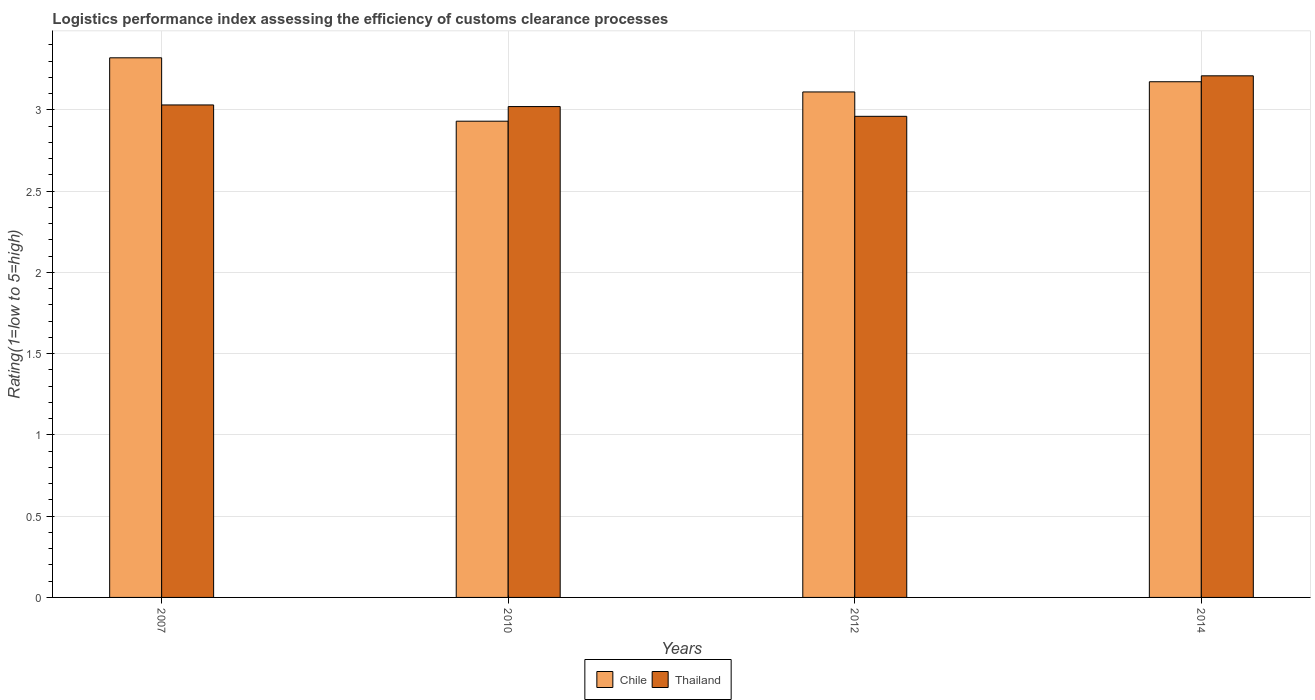How many groups of bars are there?
Offer a very short reply. 4. Are the number of bars per tick equal to the number of legend labels?
Your answer should be very brief. Yes. What is the Logistic performance index in Chile in 2007?
Provide a succinct answer. 3.32. Across all years, what is the maximum Logistic performance index in Thailand?
Offer a very short reply. 3.21. Across all years, what is the minimum Logistic performance index in Thailand?
Make the answer very short. 2.96. In which year was the Logistic performance index in Chile minimum?
Provide a succinct answer. 2010. What is the total Logistic performance index in Chile in the graph?
Make the answer very short. 12.53. What is the difference between the Logistic performance index in Thailand in 2007 and that in 2014?
Your answer should be compact. -0.18. What is the difference between the Logistic performance index in Chile in 2010 and the Logistic performance index in Thailand in 2012?
Keep it short and to the point. -0.03. What is the average Logistic performance index in Chile per year?
Provide a succinct answer. 3.13. In the year 2014, what is the difference between the Logistic performance index in Thailand and Logistic performance index in Chile?
Make the answer very short. 0.04. What is the ratio of the Logistic performance index in Thailand in 2007 to that in 2014?
Make the answer very short. 0.94. Is the Logistic performance index in Chile in 2007 less than that in 2014?
Offer a very short reply. No. Is the difference between the Logistic performance index in Thailand in 2007 and 2014 greater than the difference between the Logistic performance index in Chile in 2007 and 2014?
Ensure brevity in your answer.  No. What is the difference between the highest and the second highest Logistic performance index in Chile?
Offer a very short reply. 0.15. What is the difference between the highest and the lowest Logistic performance index in Chile?
Give a very brief answer. 0.39. Is the sum of the Logistic performance index in Chile in 2012 and 2014 greater than the maximum Logistic performance index in Thailand across all years?
Keep it short and to the point. Yes. What does the 1st bar from the left in 2007 represents?
Give a very brief answer. Chile. What does the 1st bar from the right in 2012 represents?
Your answer should be very brief. Thailand. How many years are there in the graph?
Provide a short and direct response. 4. What is the difference between two consecutive major ticks on the Y-axis?
Give a very brief answer. 0.5. Are the values on the major ticks of Y-axis written in scientific E-notation?
Give a very brief answer. No. Does the graph contain any zero values?
Offer a very short reply. No. Does the graph contain grids?
Provide a short and direct response. Yes. Where does the legend appear in the graph?
Offer a very short reply. Bottom center. What is the title of the graph?
Ensure brevity in your answer.  Logistics performance index assessing the efficiency of customs clearance processes. What is the label or title of the X-axis?
Provide a short and direct response. Years. What is the label or title of the Y-axis?
Make the answer very short. Rating(1=low to 5=high). What is the Rating(1=low to 5=high) of Chile in 2007?
Your answer should be compact. 3.32. What is the Rating(1=low to 5=high) in Thailand in 2007?
Provide a short and direct response. 3.03. What is the Rating(1=low to 5=high) of Chile in 2010?
Your answer should be very brief. 2.93. What is the Rating(1=low to 5=high) in Thailand in 2010?
Give a very brief answer. 3.02. What is the Rating(1=low to 5=high) of Chile in 2012?
Offer a very short reply. 3.11. What is the Rating(1=low to 5=high) in Thailand in 2012?
Keep it short and to the point. 2.96. What is the Rating(1=low to 5=high) of Chile in 2014?
Your answer should be compact. 3.17. What is the Rating(1=low to 5=high) of Thailand in 2014?
Your answer should be compact. 3.21. Across all years, what is the maximum Rating(1=low to 5=high) of Chile?
Offer a terse response. 3.32. Across all years, what is the maximum Rating(1=low to 5=high) of Thailand?
Provide a short and direct response. 3.21. Across all years, what is the minimum Rating(1=low to 5=high) in Chile?
Ensure brevity in your answer.  2.93. Across all years, what is the minimum Rating(1=low to 5=high) of Thailand?
Keep it short and to the point. 2.96. What is the total Rating(1=low to 5=high) in Chile in the graph?
Offer a very short reply. 12.53. What is the total Rating(1=low to 5=high) of Thailand in the graph?
Ensure brevity in your answer.  12.22. What is the difference between the Rating(1=low to 5=high) in Chile in 2007 and that in 2010?
Ensure brevity in your answer.  0.39. What is the difference between the Rating(1=low to 5=high) in Chile in 2007 and that in 2012?
Your answer should be compact. 0.21. What is the difference between the Rating(1=low to 5=high) of Thailand in 2007 and that in 2012?
Offer a very short reply. 0.07. What is the difference between the Rating(1=low to 5=high) in Chile in 2007 and that in 2014?
Keep it short and to the point. 0.15. What is the difference between the Rating(1=low to 5=high) of Thailand in 2007 and that in 2014?
Give a very brief answer. -0.18. What is the difference between the Rating(1=low to 5=high) in Chile in 2010 and that in 2012?
Your response must be concise. -0.18. What is the difference between the Rating(1=low to 5=high) of Thailand in 2010 and that in 2012?
Your response must be concise. 0.06. What is the difference between the Rating(1=low to 5=high) in Chile in 2010 and that in 2014?
Provide a succinct answer. -0.24. What is the difference between the Rating(1=low to 5=high) of Thailand in 2010 and that in 2014?
Your response must be concise. -0.19. What is the difference between the Rating(1=low to 5=high) in Chile in 2012 and that in 2014?
Give a very brief answer. -0.06. What is the difference between the Rating(1=low to 5=high) in Thailand in 2012 and that in 2014?
Offer a very short reply. -0.25. What is the difference between the Rating(1=low to 5=high) of Chile in 2007 and the Rating(1=low to 5=high) of Thailand in 2012?
Your answer should be compact. 0.36. What is the difference between the Rating(1=low to 5=high) in Chile in 2007 and the Rating(1=low to 5=high) in Thailand in 2014?
Make the answer very short. 0.11. What is the difference between the Rating(1=low to 5=high) in Chile in 2010 and the Rating(1=low to 5=high) in Thailand in 2012?
Offer a terse response. -0.03. What is the difference between the Rating(1=low to 5=high) in Chile in 2010 and the Rating(1=low to 5=high) in Thailand in 2014?
Provide a succinct answer. -0.28. What is the difference between the Rating(1=low to 5=high) in Chile in 2012 and the Rating(1=low to 5=high) in Thailand in 2014?
Your response must be concise. -0.1. What is the average Rating(1=low to 5=high) in Chile per year?
Your response must be concise. 3.13. What is the average Rating(1=low to 5=high) in Thailand per year?
Ensure brevity in your answer.  3.05. In the year 2007, what is the difference between the Rating(1=low to 5=high) of Chile and Rating(1=low to 5=high) of Thailand?
Your answer should be very brief. 0.29. In the year 2010, what is the difference between the Rating(1=low to 5=high) of Chile and Rating(1=low to 5=high) of Thailand?
Give a very brief answer. -0.09. In the year 2014, what is the difference between the Rating(1=low to 5=high) of Chile and Rating(1=low to 5=high) of Thailand?
Your answer should be compact. -0.04. What is the ratio of the Rating(1=low to 5=high) of Chile in 2007 to that in 2010?
Make the answer very short. 1.13. What is the ratio of the Rating(1=low to 5=high) in Thailand in 2007 to that in 2010?
Offer a very short reply. 1. What is the ratio of the Rating(1=low to 5=high) in Chile in 2007 to that in 2012?
Ensure brevity in your answer.  1.07. What is the ratio of the Rating(1=low to 5=high) of Thailand in 2007 to that in 2012?
Offer a terse response. 1.02. What is the ratio of the Rating(1=low to 5=high) in Chile in 2007 to that in 2014?
Offer a very short reply. 1.05. What is the ratio of the Rating(1=low to 5=high) of Thailand in 2007 to that in 2014?
Offer a terse response. 0.94. What is the ratio of the Rating(1=low to 5=high) of Chile in 2010 to that in 2012?
Keep it short and to the point. 0.94. What is the ratio of the Rating(1=low to 5=high) in Thailand in 2010 to that in 2012?
Your answer should be very brief. 1.02. What is the ratio of the Rating(1=low to 5=high) of Chile in 2010 to that in 2014?
Your answer should be compact. 0.92. What is the ratio of the Rating(1=low to 5=high) in Thailand in 2010 to that in 2014?
Make the answer very short. 0.94. What is the ratio of the Rating(1=low to 5=high) in Chile in 2012 to that in 2014?
Ensure brevity in your answer.  0.98. What is the ratio of the Rating(1=low to 5=high) in Thailand in 2012 to that in 2014?
Ensure brevity in your answer.  0.92. What is the difference between the highest and the second highest Rating(1=low to 5=high) of Chile?
Give a very brief answer. 0.15. What is the difference between the highest and the second highest Rating(1=low to 5=high) of Thailand?
Provide a succinct answer. 0.18. What is the difference between the highest and the lowest Rating(1=low to 5=high) in Chile?
Your answer should be very brief. 0.39. What is the difference between the highest and the lowest Rating(1=low to 5=high) of Thailand?
Give a very brief answer. 0.25. 